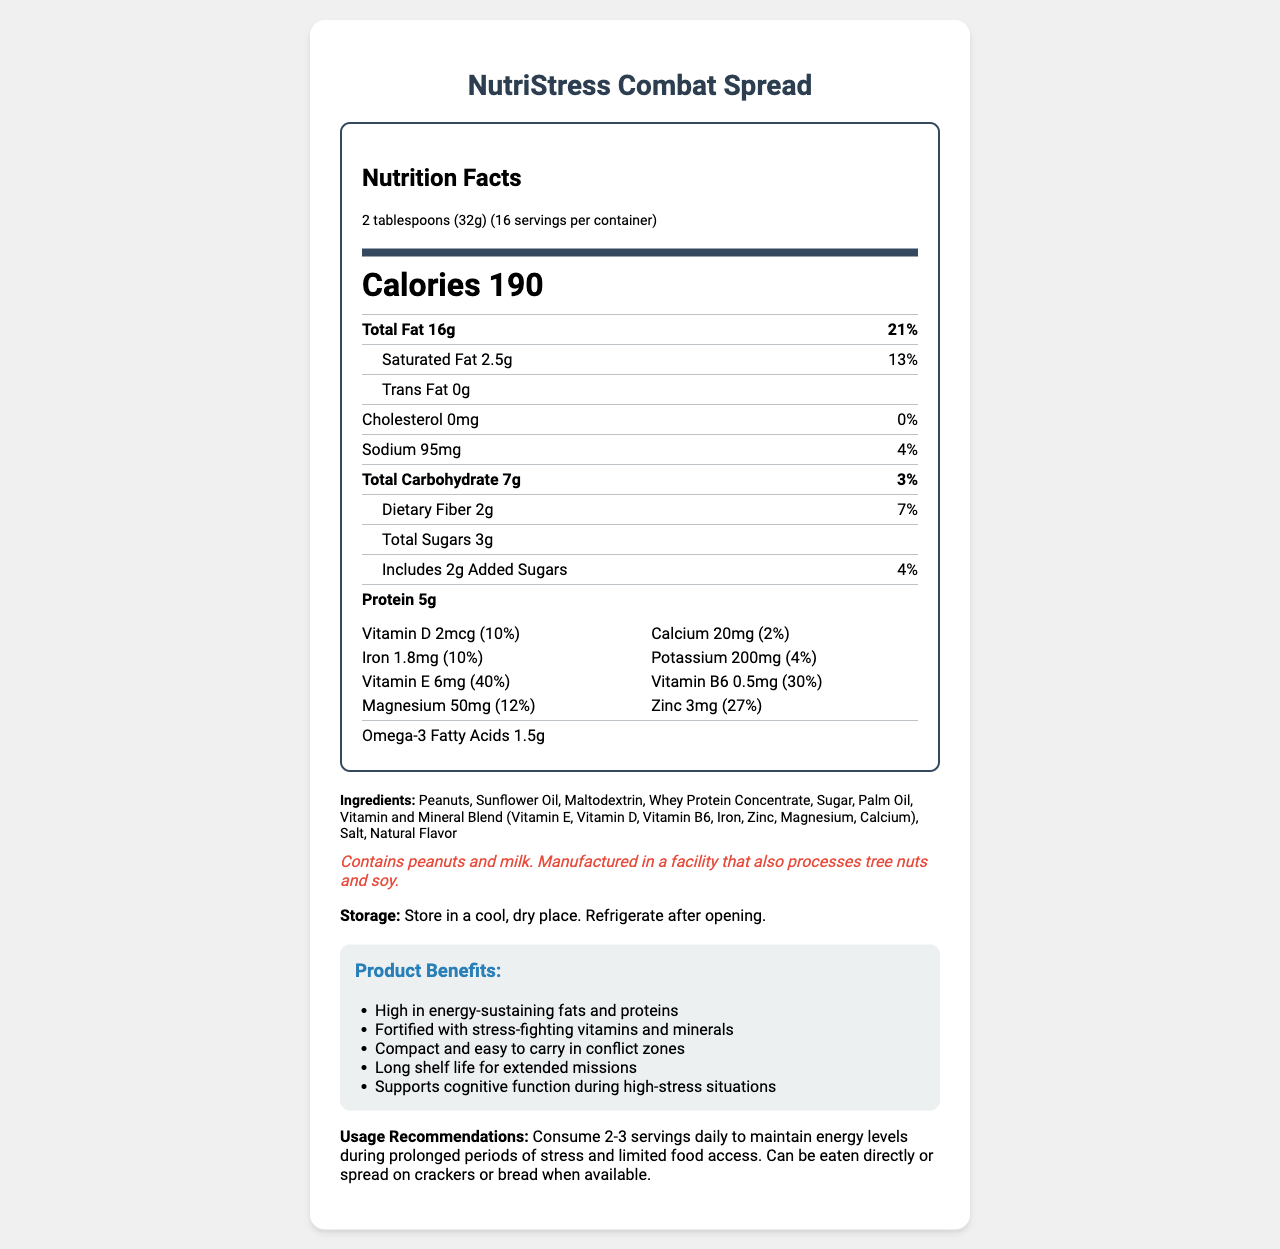what is the serving size? The serving size is stated at the very beginning of the nutrition facts information in the document.
Answer: 2 tablespoons (32g) how many servings are in the container? The document specifies that there are 16 servings per container.
Answer: 16 what is the calorie count per serving? The document indicates that each serving contains 190 calories.
Answer: 190 what is the amount of protein per serving? The document lists that each serving has 5 grams of protein.
Answer: 5g which vitamin has the highest daily value percentage per serving? Vitamin E has a daily value of 40%, which is the highest among all the vitamins and minerals listed.
Answer: Vitamin E what are the storage instructions for the product? The storage instructions are provided in the document under the storage information section.
Answer: Store in a cool, dry place. Refrigerate after opening. what two allergens are contained in the product? A. Wheat and Soy B. Peanuts and Milk C. Eggs and Fish The allergen information in the document reveals that the product contains peanuts and milk.
Answer: B. Peanuts and Milk how much dietary fiber is in one serving? The document lists that there are 2 grams of dietary fiber per serving.
Answer: 2g which ingredient contributes most likely to the high fat content? Peanuts are listed as the first ingredient, suggesting they are the primary contributor to the product's total fat content.
Answer: Peanuts what is the total carbohydrate content in a serving? The document specifies that each serving contains 7 grams of total carbohydrates.
Answer: 7g is the product designed to support cognitive function in high-stress situations? (Yes/No) One of the product benefits mentioned is that it supports cognitive function during high-stress situations.
Answer: Yes summarize the main idea of the document. The document presents comprehensive details about the NutriStress Combat Spread, including its nutritional content, benefits, and how to use and store the product.
Answer: The document provides detailed nutrition facts, ingredient information, product benefits, and usage recommendations for NutriStress Combat Spread, a fortified, calorie-dense spread designed to maintain energy levels during prolonged periods of stress and limited food access. how many grams of omega-3 fatty acids does the product contain per serving? The document lists that each serving contains 1.5 grams of omega-3 fatty acids.
Answer: 1.5g how much iron does one serving provide? According to the document, each serving contains 1.8 milligrams of iron.
Answer: 1.8mg which ingredient is not listed in the product? A. Maltodextrin B. Sunflower Oil C. Coconut Oil D. Whey Protein Concentrate Coconut Oil is not listed among the ingredients in the document.
Answer: C. Coconut Oil who is the manufacturer of the product? The document does not provide information about the manufacturer.
Answer: Cannot be determined what daily value percentage of magnesium does the product provide? The document specifies that each serving provides 12% of the daily value of magnesium.
Answer: 12% 